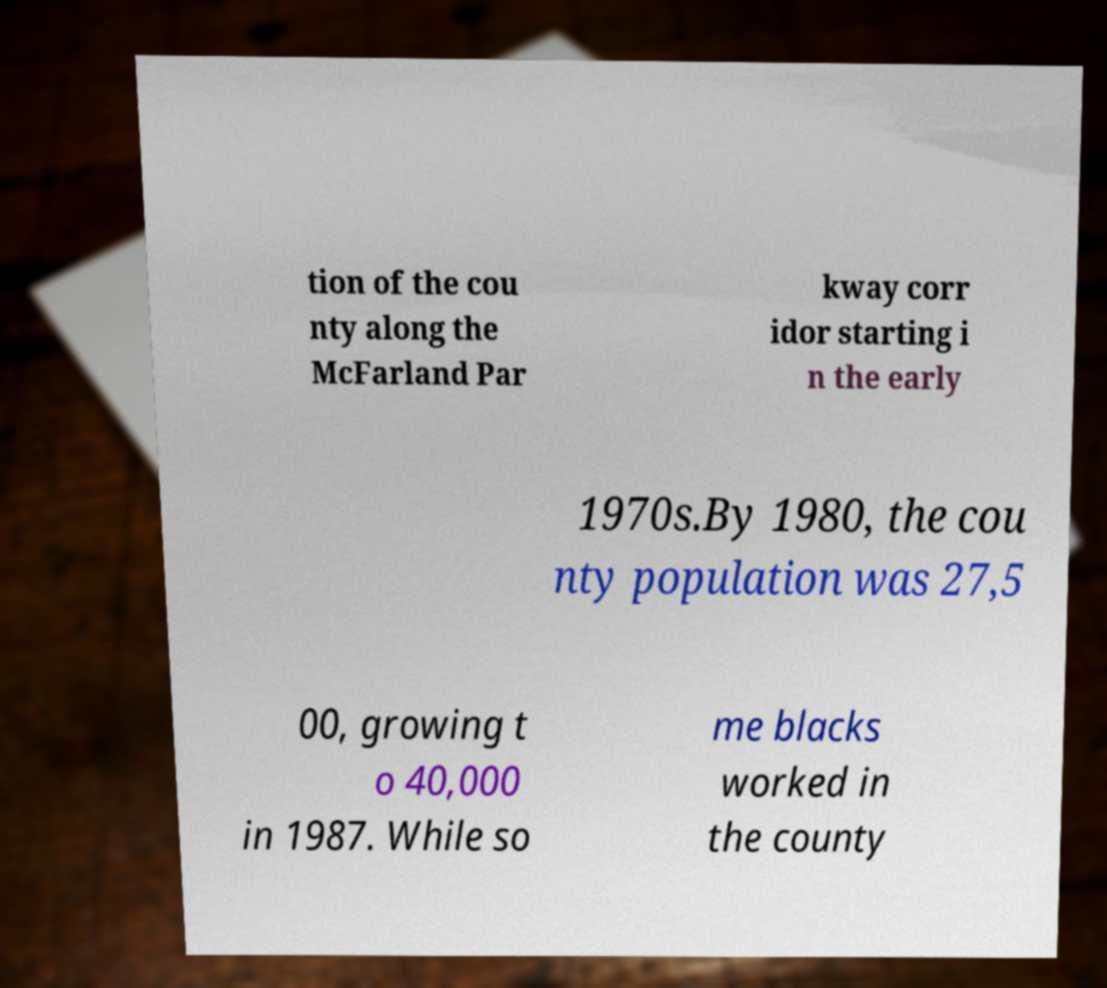Please identify and transcribe the text found in this image. tion of the cou nty along the McFarland Par kway corr idor starting i n the early 1970s.By 1980, the cou nty population was 27,5 00, growing t o 40,000 in 1987. While so me blacks worked in the county 